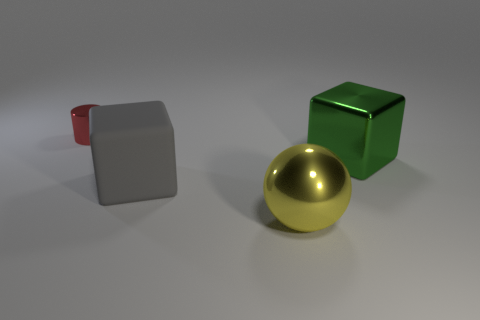Are there more large gray matte cubes than large blocks?
Your answer should be very brief. No. What size is the object that is in front of the block to the left of the block that is behind the big gray rubber thing?
Make the answer very short. Large. Do the matte object and the shiny thing that is to the left of the gray object have the same size?
Provide a short and direct response. No. Is the number of large green objects in front of the big gray matte block less than the number of small brown things?
Your response must be concise. No. How many other tiny shiny objects are the same color as the small thing?
Offer a very short reply. 0. Are there fewer purple objects than tiny red metallic objects?
Provide a succinct answer. Yes. Are the green cube and the big sphere made of the same material?
Provide a succinct answer. Yes. How many other things are there of the same size as the ball?
Your answer should be very brief. 2. What is the color of the large thing behind the big block that is left of the green metallic thing?
Your response must be concise. Green. What number of other objects are the same shape as the green thing?
Provide a succinct answer. 1. 